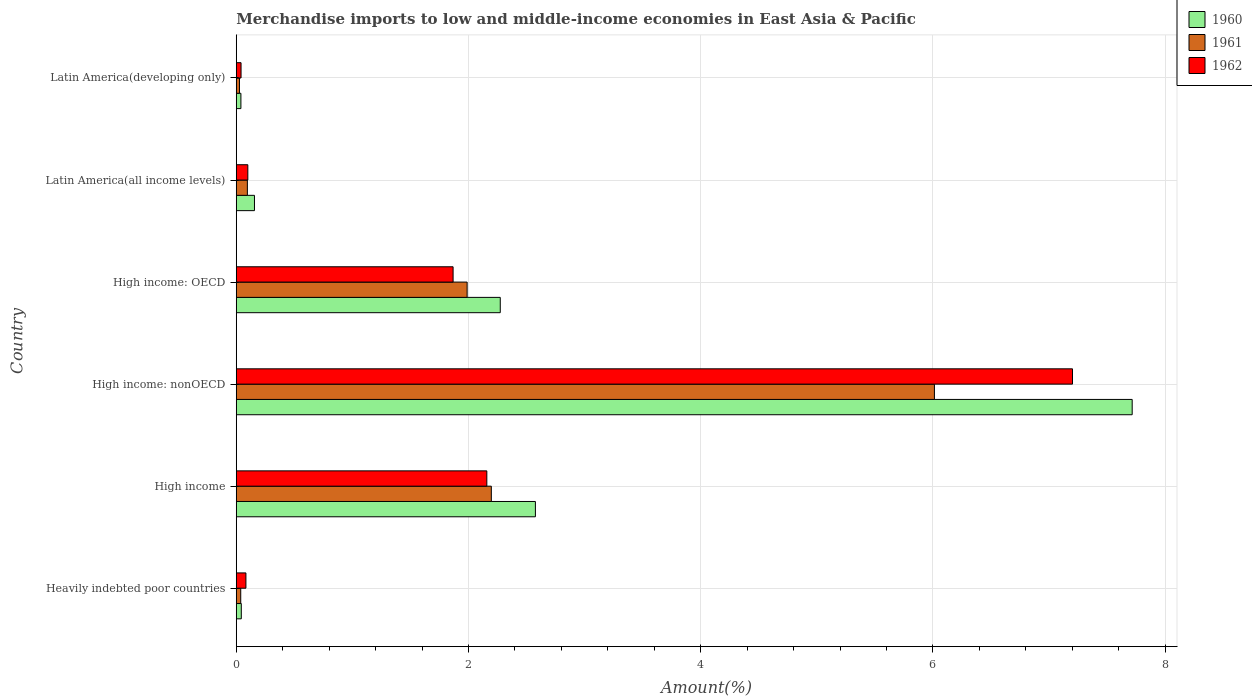Are the number of bars per tick equal to the number of legend labels?
Offer a very short reply. Yes. What is the label of the 2nd group of bars from the top?
Offer a very short reply. Latin America(all income levels). In how many cases, is the number of bars for a given country not equal to the number of legend labels?
Offer a terse response. 0. What is the percentage of amount earned from merchandise imports in 1961 in Latin America(all income levels)?
Provide a short and direct response. 0.1. Across all countries, what is the maximum percentage of amount earned from merchandise imports in 1962?
Offer a very short reply. 7.2. Across all countries, what is the minimum percentage of amount earned from merchandise imports in 1961?
Your answer should be very brief. 0.03. In which country was the percentage of amount earned from merchandise imports in 1961 maximum?
Give a very brief answer. High income: nonOECD. In which country was the percentage of amount earned from merchandise imports in 1962 minimum?
Give a very brief answer. Latin America(developing only). What is the total percentage of amount earned from merchandise imports in 1962 in the graph?
Offer a very short reply. 11.45. What is the difference between the percentage of amount earned from merchandise imports in 1960 in High income: nonOECD and that in Latin America(all income levels)?
Offer a terse response. 7.56. What is the difference between the percentage of amount earned from merchandise imports in 1962 in Latin America(all income levels) and the percentage of amount earned from merchandise imports in 1961 in Latin America(developing only)?
Offer a very short reply. 0.07. What is the average percentage of amount earned from merchandise imports in 1962 per country?
Give a very brief answer. 1.91. What is the difference between the percentage of amount earned from merchandise imports in 1960 and percentage of amount earned from merchandise imports in 1961 in High income?
Provide a short and direct response. 0.38. In how many countries, is the percentage of amount earned from merchandise imports in 1961 greater than 5.2 %?
Make the answer very short. 1. What is the ratio of the percentage of amount earned from merchandise imports in 1962 in High income: nonOECD to that in Latin America(developing only)?
Keep it short and to the point. 174.29. What is the difference between the highest and the second highest percentage of amount earned from merchandise imports in 1962?
Offer a terse response. 5.04. What is the difference between the highest and the lowest percentage of amount earned from merchandise imports in 1962?
Provide a short and direct response. 7.16. In how many countries, is the percentage of amount earned from merchandise imports in 1961 greater than the average percentage of amount earned from merchandise imports in 1961 taken over all countries?
Give a very brief answer. 3. Is it the case that in every country, the sum of the percentage of amount earned from merchandise imports in 1962 and percentage of amount earned from merchandise imports in 1960 is greater than the percentage of amount earned from merchandise imports in 1961?
Offer a very short reply. Yes. Are all the bars in the graph horizontal?
Provide a short and direct response. Yes. Are the values on the major ticks of X-axis written in scientific E-notation?
Keep it short and to the point. No. Does the graph contain any zero values?
Make the answer very short. No. How many legend labels are there?
Provide a succinct answer. 3. How are the legend labels stacked?
Offer a terse response. Vertical. What is the title of the graph?
Provide a succinct answer. Merchandise imports to low and middle-income economies in East Asia & Pacific. What is the label or title of the X-axis?
Your answer should be compact. Amount(%). What is the Amount(%) of 1960 in Heavily indebted poor countries?
Keep it short and to the point. 0.04. What is the Amount(%) in 1961 in Heavily indebted poor countries?
Make the answer very short. 0.04. What is the Amount(%) in 1962 in Heavily indebted poor countries?
Provide a short and direct response. 0.08. What is the Amount(%) of 1960 in High income?
Offer a terse response. 2.58. What is the Amount(%) in 1961 in High income?
Your answer should be very brief. 2.2. What is the Amount(%) of 1962 in High income?
Offer a very short reply. 2.16. What is the Amount(%) of 1960 in High income: nonOECD?
Your answer should be compact. 7.72. What is the Amount(%) of 1961 in High income: nonOECD?
Offer a very short reply. 6.01. What is the Amount(%) of 1962 in High income: nonOECD?
Your answer should be very brief. 7.2. What is the Amount(%) of 1960 in High income: OECD?
Provide a succinct answer. 2.27. What is the Amount(%) in 1961 in High income: OECD?
Make the answer very short. 1.99. What is the Amount(%) of 1962 in High income: OECD?
Provide a short and direct response. 1.87. What is the Amount(%) of 1960 in Latin America(all income levels)?
Provide a succinct answer. 0.16. What is the Amount(%) in 1961 in Latin America(all income levels)?
Your response must be concise. 0.1. What is the Amount(%) in 1962 in Latin America(all income levels)?
Offer a very short reply. 0.1. What is the Amount(%) in 1960 in Latin America(developing only)?
Your answer should be compact. 0.04. What is the Amount(%) in 1961 in Latin America(developing only)?
Your response must be concise. 0.03. What is the Amount(%) in 1962 in Latin America(developing only)?
Give a very brief answer. 0.04. Across all countries, what is the maximum Amount(%) in 1960?
Provide a short and direct response. 7.72. Across all countries, what is the maximum Amount(%) in 1961?
Provide a succinct answer. 6.01. Across all countries, what is the maximum Amount(%) of 1962?
Provide a succinct answer. 7.2. Across all countries, what is the minimum Amount(%) of 1960?
Your response must be concise. 0.04. Across all countries, what is the minimum Amount(%) of 1961?
Provide a short and direct response. 0.03. Across all countries, what is the minimum Amount(%) in 1962?
Make the answer very short. 0.04. What is the total Amount(%) in 1960 in the graph?
Offer a very short reply. 12.81. What is the total Amount(%) in 1961 in the graph?
Your answer should be compact. 10.36. What is the total Amount(%) in 1962 in the graph?
Offer a very short reply. 11.45. What is the difference between the Amount(%) of 1960 in Heavily indebted poor countries and that in High income?
Your answer should be very brief. -2.53. What is the difference between the Amount(%) of 1961 in Heavily indebted poor countries and that in High income?
Your response must be concise. -2.16. What is the difference between the Amount(%) of 1962 in Heavily indebted poor countries and that in High income?
Ensure brevity in your answer.  -2.07. What is the difference between the Amount(%) of 1960 in Heavily indebted poor countries and that in High income: nonOECD?
Offer a very short reply. -7.67. What is the difference between the Amount(%) of 1961 in Heavily indebted poor countries and that in High income: nonOECD?
Ensure brevity in your answer.  -5.97. What is the difference between the Amount(%) of 1962 in Heavily indebted poor countries and that in High income: nonOECD?
Provide a short and direct response. -7.12. What is the difference between the Amount(%) of 1960 in Heavily indebted poor countries and that in High income: OECD?
Provide a short and direct response. -2.23. What is the difference between the Amount(%) of 1961 in Heavily indebted poor countries and that in High income: OECD?
Offer a terse response. -1.95. What is the difference between the Amount(%) in 1962 in Heavily indebted poor countries and that in High income: OECD?
Offer a terse response. -1.78. What is the difference between the Amount(%) of 1960 in Heavily indebted poor countries and that in Latin America(all income levels)?
Your answer should be very brief. -0.11. What is the difference between the Amount(%) of 1961 in Heavily indebted poor countries and that in Latin America(all income levels)?
Ensure brevity in your answer.  -0.06. What is the difference between the Amount(%) in 1962 in Heavily indebted poor countries and that in Latin America(all income levels)?
Ensure brevity in your answer.  -0.02. What is the difference between the Amount(%) in 1960 in Heavily indebted poor countries and that in Latin America(developing only)?
Your response must be concise. 0. What is the difference between the Amount(%) of 1961 in Heavily indebted poor countries and that in Latin America(developing only)?
Offer a very short reply. 0.01. What is the difference between the Amount(%) in 1962 in Heavily indebted poor countries and that in Latin America(developing only)?
Your answer should be very brief. 0.04. What is the difference between the Amount(%) of 1960 in High income and that in High income: nonOECD?
Offer a very short reply. -5.14. What is the difference between the Amount(%) of 1961 in High income and that in High income: nonOECD?
Keep it short and to the point. -3.82. What is the difference between the Amount(%) of 1962 in High income and that in High income: nonOECD?
Make the answer very short. -5.04. What is the difference between the Amount(%) of 1960 in High income and that in High income: OECD?
Provide a short and direct response. 0.3. What is the difference between the Amount(%) of 1961 in High income and that in High income: OECD?
Your answer should be very brief. 0.21. What is the difference between the Amount(%) of 1962 in High income and that in High income: OECD?
Provide a succinct answer. 0.29. What is the difference between the Amount(%) of 1960 in High income and that in Latin America(all income levels)?
Provide a succinct answer. 2.42. What is the difference between the Amount(%) in 1961 in High income and that in Latin America(all income levels)?
Your answer should be compact. 2.1. What is the difference between the Amount(%) of 1962 in High income and that in Latin America(all income levels)?
Make the answer very short. 2.06. What is the difference between the Amount(%) of 1960 in High income and that in Latin America(developing only)?
Give a very brief answer. 2.54. What is the difference between the Amount(%) of 1961 in High income and that in Latin America(developing only)?
Keep it short and to the point. 2.17. What is the difference between the Amount(%) in 1962 in High income and that in Latin America(developing only)?
Your response must be concise. 2.12. What is the difference between the Amount(%) in 1960 in High income: nonOECD and that in High income: OECD?
Keep it short and to the point. 5.44. What is the difference between the Amount(%) of 1961 in High income: nonOECD and that in High income: OECD?
Your response must be concise. 4.02. What is the difference between the Amount(%) in 1962 in High income: nonOECD and that in High income: OECD?
Provide a short and direct response. 5.33. What is the difference between the Amount(%) in 1960 in High income: nonOECD and that in Latin America(all income levels)?
Your response must be concise. 7.56. What is the difference between the Amount(%) of 1961 in High income: nonOECD and that in Latin America(all income levels)?
Your answer should be very brief. 5.92. What is the difference between the Amount(%) in 1962 in High income: nonOECD and that in Latin America(all income levels)?
Ensure brevity in your answer.  7.1. What is the difference between the Amount(%) in 1960 in High income: nonOECD and that in Latin America(developing only)?
Offer a very short reply. 7.68. What is the difference between the Amount(%) of 1961 in High income: nonOECD and that in Latin America(developing only)?
Offer a very short reply. 5.99. What is the difference between the Amount(%) of 1962 in High income: nonOECD and that in Latin America(developing only)?
Keep it short and to the point. 7.16. What is the difference between the Amount(%) of 1960 in High income: OECD and that in Latin America(all income levels)?
Offer a terse response. 2.12. What is the difference between the Amount(%) in 1961 in High income: OECD and that in Latin America(all income levels)?
Your response must be concise. 1.89. What is the difference between the Amount(%) of 1962 in High income: OECD and that in Latin America(all income levels)?
Your response must be concise. 1.77. What is the difference between the Amount(%) in 1960 in High income: OECD and that in Latin America(developing only)?
Offer a terse response. 2.23. What is the difference between the Amount(%) of 1961 in High income: OECD and that in Latin America(developing only)?
Your answer should be compact. 1.96. What is the difference between the Amount(%) of 1962 in High income: OECD and that in Latin America(developing only)?
Keep it short and to the point. 1.83. What is the difference between the Amount(%) of 1960 in Latin America(all income levels) and that in Latin America(developing only)?
Make the answer very short. 0.12. What is the difference between the Amount(%) in 1961 in Latin America(all income levels) and that in Latin America(developing only)?
Your answer should be compact. 0.07. What is the difference between the Amount(%) of 1962 in Latin America(all income levels) and that in Latin America(developing only)?
Keep it short and to the point. 0.06. What is the difference between the Amount(%) of 1960 in Heavily indebted poor countries and the Amount(%) of 1961 in High income?
Give a very brief answer. -2.15. What is the difference between the Amount(%) of 1960 in Heavily indebted poor countries and the Amount(%) of 1962 in High income?
Offer a very short reply. -2.11. What is the difference between the Amount(%) of 1961 in Heavily indebted poor countries and the Amount(%) of 1962 in High income?
Offer a terse response. -2.12. What is the difference between the Amount(%) of 1960 in Heavily indebted poor countries and the Amount(%) of 1961 in High income: nonOECD?
Your answer should be very brief. -5.97. What is the difference between the Amount(%) in 1960 in Heavily indebted poor countries and the Amount(%) in 1962 in High income: nonOECD?
Provide a succinct answer. -7.16. What is the difference between the Amount(%) of 1961 in Heavily indebted poor countries and the Amount(%) of 1962 in High income: nonOECD?
Your answer should be compact. -7.16. What is the difference between the Amount(%) of 1960 in Heavily indebted poor countries and the Amount(%) of 1961 in High income: OECD?
Offer a terse response. -1.95. What is the difference between the Amount(%) in 1960 in Heavily indebted poor countries and the Amount(%) in 1962 in High income: OECD?
Offer a terse response. -1.82. What is the difference between the Amount(%) of 1961 in Heavily indebted poor countries and the Amount(%) of 1962 in High income: OECD?
Your response must be concise. -1.83. What is the difference between the Amount(%) in 1960 in Heavily indebted poor countries and the Amount(%) in 1961 in Latin America(all income levels)?
Your answer should be compact. -0.05. What is the difference between the Amount(%) in 1960 in Heavily indebted poor countries and the Amount(%) in 1962 in Latin America(all income levels)?
Keep it short and to the point. -0.06. What is the difference between the Amount(%) of 1961 in Heavily indebted poor countries and the Amount(%) of 1962 in Latin America(all income levels)?
Your answer should be compact. -0.06. What is the difference between the Amount(%) in 1960 in Heavily indebted poor countries and the Amount(%) in 1961 in Latin America(developing only)?
Give a very brief answer. 0.02. What is the difference between the Amount(%) in 1960 in Heavily indebted poor countries and the Amount(%) in 1962 in Latin America(developing only)?
Keep it short and to the point. 0. What is the difference between the Amount(%) in 1961 in Heavily indebted poor countries and the Amount(%) in 1962 in Latin America(developing only)?
Your response must be concise. -0. What is the difference between the Amount(%) in 1960 in High income and the Amount(%) in 1961 in High income: nonOECD?
Provide a short and direct response. -3.44. What is the difference between the Amount(%) of 1960 in High income and the Amount(%) of 1962 in High income: nonOECD?
Provide a short and direct response. -4.63. What is the difference between the Amount(%) in 1961 in High income and the Amount(%) in 1962 in High income: nonOECD?
Make the answer very short. -5.01. What is the difference between the Amount(%) in 1960 in High income and the Amount(%) in 1961 in High income: OECD?
Offer a very short reply. 0.59. What is the difference between the Amount(%) of 1960 in High income and the Amount(%) of 1962 in High income: OECD?
Your response must be concise. 0.71. What is the difference between the Amount(%) in 1961 in High income and the Amount(%) in 1962 in High income: OECD?
Provide a short and direct response. 0.33. What is the difference between the Amount(%) in 1960 in High income and the Amount(%) in 1961 in Latin America(all income levels)?
Give a very brief answer. 2.48. What is the difference between the Amount(%) of 1960 in High income and the Amount(%) of 1962 in Latin America(all income levels)?
Offer a terse response. 2.48. What is the difference between the Amount(%) of 1961 in High income and the Amount(%) of 1962 in Latin America(all income levels)?
Your answer should be compact. 2.1. What is the difference between the Amount(%) of 1960 in High income and the Amount(%) of 1961 in Latin America(developing only)?
Offer a terse response. 2.55. What is the difference between the Amount(%) of 1960 in High income and the Amount(%) of 1962 in Latin America(developing only)?
Provide a short and direct response. 2.54. What is the difference between the Amount(%) in 1961 in High income and the Amount(%) in 1962 in Latin America(developing only)?
Your answer should be compact. 2.16. What is the difference between the Amount(%) of 1960 in High income: nonOECD and the Amount(%) of 1961 in High income: OECD?
Give a very brief answer. 5.73. What is the difference between the Amount(%) of 1960 in High income: nonOECD and the Amount(%) of 1962 in High income: OECD?
Keep it short and to the point. 5.85. What is the difference between the Amount(%) in 1961 in High income: nonOECD and the Amount(%) in 1962 in High income: OECD?
Offer a terse response. 4.15. What is the difference between the Amount(%) in 1960 in High income: nonOECD and the Amount(%) in 1961 in Latin America(all income levels)?
Make the answer very short. 7.62. What is the difference between the Amount(%) in 1960 in High income: nonOECD and the Amount(%) in 1962 in Latin America(all income levels)?
Your answer should be very brief. 7.62. What is the difference between the Amount(%) in 1961 in High income: nonOECD and the Amount(%) in 1962 in Latin America(all income levels)?
Offer a terse response. 5.91. What is the difference between the Amount(%) of 1960 in High income: nonOECD and the Amount(%) of 1961 in Latin America(developing only)?
Offer a terse response. 7.69. What is the difference between the Amount(%) in 1960 in High income: nonOECD and the Amount(%) in 1962 in Latin America(developing only)?
Your answer should be very brief. 7.67. What is the difference between the Amount(%) of 1961 in High income: nonOECD and the Amount(%) of 1962 in Latin America(developing only)?
Offer a terse response. 5.97. What is the difference between the Amount(%) of 1960 in High income: OECD and the Amount(%) of 1961 in Latin America(all income levels)?
Provide a succinct answer. 2.18. What is the difference between the Amount(%) of 1960 in High income: OECD and the Amount(%) of 1962 in Latin America(all income levels)?
Your answer should be very brief. 2.17. What is the difference between the Amount(%) of 1961 in High income: OECD and the Amount(%) of 1962 in Latin America(all income levels)?
Your response must be concise. 1.89. What is the difference between the Amount(%) in 1960 in High income: OECD and the Amount(%) in 1961 in Latin America(developing only)?
Make the answer very short. 2.25. What is the difference between the Amount(%) of 1960 in High income: OECD and the Amount(%) of 1962 in Latin America(developing only)?
Your response must be concise. 2.23. What is the difference between the Amount(%) of 1961 in High income: OECD and the Amount(%) of 1962 in Latin America(developing only)?
Your answer should be compact. 1.95. What is the difference between the Amount(%) in 1960 in Latin America(all income levels) and the Amount(%) in 1961 in Latin America(developing only)?
Keep it short and to the point. 0.13. What is the difference between the Amount(%) in 1960 in Latin America(all income levels) and the Amount(%) in 1962 in Latin America(developing only)?
Provide a succinct answer. 0.12. What is the difference between the Amount(%) of 1961 in Latin America(all income levels) and the Amount(%) of 1962 in Latin America(developing only)?
Give a very brief answer. 0.05. What is the average Amount(%) of 1960 per country?
Keep it short and to the point. 2.13. What is the average Amount(%) of 1961 per country?
Your answer should be very brief. 1.73. What is the average Amount(%) in 1962 per country?
Offer a very short reply. 1.91. What is the difference between the Amount(%) in 1960 and Amount(%) in 1961 in Heavily indebted poor countries?
Your answer should be compact. 0. What is the difference between the Amount(%) in 1960 and Amount(%) in 1962 in Heavily indebted poor countries?
Give a very brief answer. -0.04. What is the difference between the Amount(%) of 1961 and Amount(%) of 1962 in Heavily indebted poor countries?
Offer a very short reply. -0.04. What is the difference between the Amount(%) in 1960 and Amount(%) in 1961 in High income?
Offer a very short reply. 0.38. What is the difference between the Amount(%) of 1960 and Amount(%) of 1962 in High income?
Make the answer very short. 0.42. What is the difference between the Amount(%) in 1961 and Amount(%) in 1962 in High income?
Make the answer very short. 0.04. What is the difference between the Amount(%) in 1960 and Amount(%) in 1961 in High income: nonOECD?
Ensure brevity in your answer.  1.7. What is the difference between the Amount(%) in 1960 and Amount(%) in 1962 in High income: nonOECD?
Your answer should be very brief. 0.51. What is the difference between the Amount(%) in 1961 and Amount(%) in 1962 in High income: nonOECD?
Offer a terse response. -1.19. What is the difference between the Amount(%) of 1960 and Amount(%) of 1961 in High income: OECD?
Give a very brief answer. 0.29. What is the difference between the Amount(%) in 1960 and Amount(%) in 1962 in High income: OECD?
Give a very brief answer. 0.41. What is the difference between the Amount(%) of 1961 and Amount(%) of 1962 in High income: OECD?
Offer a terse response. 0.12. What is the difference between the Amount(%) of 1960 and Amount(%) of 1961 in Latin America(all income levels)?
Offer a very short reply. 0.06. What is the difference between the Amount(%) in 1960 and Amount(%) in 1962 in Latin America(all income levels)?
Offer a terse response. 0.06. What is the difference between the Amount(%) in 1961 and Amount(%) in 1962 in Latin America(all income levels)?
Offer a very short reply. -0. What is the difference between the Amount(%) in 1960 and Amount(%) in 1961 in Latin America(developing only)?
Keep it short and to the point. 0.01. What is the difference between the Amount(%) of 1960 and Amount(%) of 1962 in Latin America(developing only)?
Make the answer very short. -0. What is the difference between the Amount(%) of 1961 and Amount(%) of 1962 in Latin America(developing only)?
Keep it short and to the point. -0.01. What is the ratio of the Amount(%) of 1960 in Heavily indebted poor countries to that in High income?
Your answer should be compact. 0.02. What is the ratio of the Amount(%) in 1961 in Heavily indebted poor countries to that in High income?
Offer a terse response. 0.02. What is the ratio of the Amount(%) of 1962 in Heavily indebted poor countries to that in High income?
Give a very brief answer. 0.04. What is the ratio of the Amount(%) of 1960 in Heavily indebted poor countries to that in High income: nonOECD?
Provide a short and direct response. 0.01. What is the ratio of the Amount(%) of 1961 in Heavily indebted poor countries to that in High income: nonOECD?
Your response must be concise. 0.01. What is the ratio of the Amount(%) of 1962 in Heavily indebted poor countries to that in High income: nonOECD?
Provide a succinct answer. 0.01. What is the ratio of the Amount(%) in 1960 in Heavily indebted poor countries to that in High income: OECD?
Offer a terse response. 0.02. What is the ratio of the Amount(%) in 1961 in Heavily indebted poor countries to that in High income: OECD?
Give a very brief answer. 0.02. What is the ratio of the Amount(%) in 1962 in Heavily indebted poor countries to that in High income: OECD?
Your answer should be very brief. 0.04. What is the ratio of the Amount(%) in 1960 in Heavily indebted poor countries to that in Latin America(all income levels)?
Keep it short and to the point. 0.28. What is the ratio of the Amount(%) of 1961 in Heavily indebted poor countries to that in Latin America(all income levels)?
Offer a terse response. 0.4. What is the ratio of the Amount(%) in 1962 in Heavily indebted poor countries to that in Latin America(all income levels)?
Provide a short and direct response. 0.84. What is the ratio of the Amount(%) in 1960 in Heavily indebted poor countries to that in Latin America(developing only)?
Keep it short and to the point. 1.08. What is the ratio of the Amount(%) in 1961 in Heavily indebted poor countries to that in Latin America(developing only)?
Make the answer very short. 1.39. What is the ratio of the Amount(%) of 1962 in Heavily indebted poor countries to that in Latin America(developing only)?
Provide a short and direct response. 2.02. What is the ratio of the Amount(%) of 1960 in High income to that in High income: nonOECD?
Make the answer very short. 0.33. What is the ratio of the Amount(%) in 1961 in High income to that in High income: nonOECD?
Provide a succinct answer. 0.37. What is the ratio of the Amount(%) of 1962 in High income to that in High income: nonOECD?
Provide a short and direct response. 0.3. What is the ratio of the Amount(%) in 1960 in High income to that in High income: OECD?
Your answer should be very brief. 1.13. What is the ratio of the Amount(%) in 1961 in High income to that in High income: OECD?
Keep it short and to the point. 1.1. What is the ratio of the Amount(%) in 1962 in High income to that in High income: OECD?
Keep it short and to the point. 1.16. What is the ratio of the Amount(%) in 1960 in High income to that in Latin America(all income levels)?
Give a very brief answer. 16.42. What is the ratio of the Amount(%) of 1961 in High income to that in Latin America(all income levels)?
Offer a terse response. 22.93. What is the ratio of the Amount(%) of 1962 in High income to that in Latin America(all income levels)?
Provide a short and direct response. 21.66. What is the ratio of the Amount(%) of 1960 in High income to that in Latin America(developing only)?
Give a very brief answer. 64.25. What is the ratio of the Amount(%) in 1961 in High income to that in Latin America(developing only)?
Offer a terse response. 79.06. What is the ratio of the Amount(%) of 1962 in High income to that in Latin America(developing only)?
Your answer should be very brief. 52.23. What is the ratio of the Amount(%) of 1960 in High income: nonOECD to that in High income: OECD?
Provide a succinct answer. 3.39. What is the ratio of the Amount(%) of 1961 in High income: nonOECD to that in High income: OECD?
Offer a terse response. 3.02. What is the ratio of the Amount(%) of 1962 in High income: nonOECD to that in High income: OECD?
Ensure brevity in your answer.  3.86. What is the ratio of the Amount(%) of 1960 in High income: nonOECD to that in Latin America(all income levels)?
Provide a short and direct response. 49.18. What is the ratio of the Amount(%) in 1961 in High income: nonOECD to that in Latin America(all income levels)?
Give a very brief answer. 62.77. What is the ratio of the Amount(%) of 1962 in High income: nonOECD to that in Latin America(all income levels)?
Offer a very short reply. 72.3. What is the ratio of the Amount(%) in 1960 in High income: nonOECD to that in Latin America(developing only)?
Make the answer very short. 192.42. What is the ratio of the Amount(%) of 1961 in High income: nonOECD to that in Latin America(developing only)?
Offer a very short reply. 216.41. What is the ratio of the Amount(%) in 1962 in High income: nonOECD to that in Latin America(developing only)?
Your answer should be compact. 174.29. What is the ratio of the Amount(%) of 1960 in High income: OECD to that in Latin America(all income levels)?
Your answer should be compact. 14.49. What is the ratio of the Amount(%) of 1961 in High income: OECD to that in Latin America(all income levels)?
Your response must be concise. 20.76. What is the ratio of the Amount(%) in 1962 in High income: OECD to that in Latin America(all income levels)?
Provide a succinct answer. 18.75. What is the ratio of the Amount(%) in 1960 in High income: OECD to that in Latin America(developing only)?
Keep it short and to the point. 56.7. What is the ratio of the Amount(%) in 1961 in High income: OECD to that in Latin America(developing only)?
Offer a terse response. 71.56. What is the ratio of the Amount(%) in 1962 in High income: OECD to that in Latin America(developing only)?
Ensure brevity in your answer.  45.19. What is the ratio of the Amount(%) of 1960 in Latin America(all income levels) to that in Latin America(developing only)?
Provide a succinct answer. 3.91. What is the ratio of the Amount(%) in 1961 in Latin America(all income levels) to that in Latin America(developing only)?
Ensure brevity in your answer.  3.45. What is the ratio of the Amount(%) of 1962 in Latin America(all income levels) to that in Latin America(developing only)?
Make the answer very short. 2.41. What is the difference between the highest and the second highest Amount(%) of 1960?
Offer a very short reply. 5.14. What is the difference between the highest and the second highest Amount(%) in 1961?
Offer a terse response. 3.82. What is the difference between the highest and the second highest Amount(%) in 1962?
Your response must be concise. 5.04. What is the difference between the highest and the lowest Amount(%) of 1960?
Provide a succinct answer. 7.68. What is the difference between the highest and the lowest Amount(%) of 1961?
Provide a succinct answer. 5.99. What is the difference between the highest and the lowest Amount(%) in 1962?
Your answer should be compact. 7.16. 